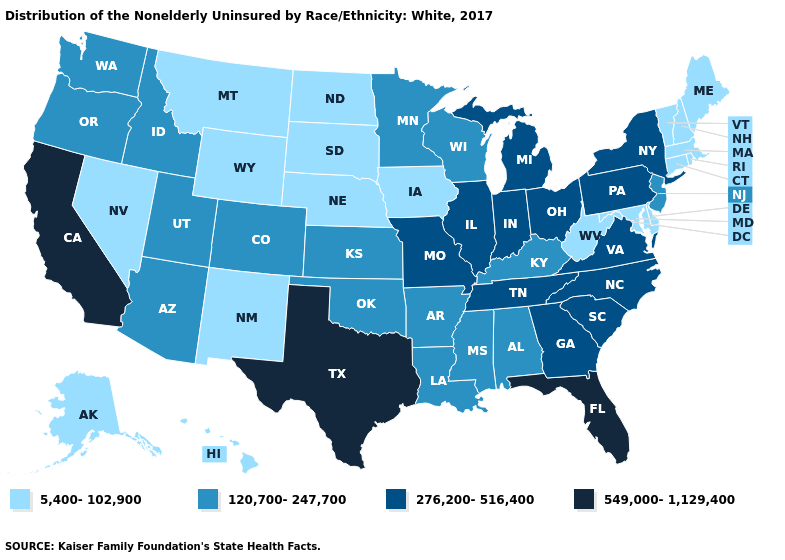Does Texas have the highest value in the USA?
Be succinct. Yes. Name the states that have a value in the range 5,400-102,900?
Give a very brief answer. Alaska, Connecticut, Delaware, Hawaii, Iowa, Maine, Maryland, Massachusetts, Montana, Nebraska, Nevada, New Hampshire, New Mexico, North Dakota, Rhode Island, South Dakota, Vermont, West Virginia, Wyoming. What is the value of Virginia?
Short answer required. 276,200-516,400. Does the map have missing data?
Give a very brief answer. No. Name the states that have a value in the range 276,200-516,400?
Concise answer only. Georgia, Illinois, Indiana, Michigan, Missouri, New York, North Carolina, Ohio, Pennsylvania, South Carolina, Tennessee, Virginia. Which states have the lowest value in the USA?
Short answer required. Alaska, Connecticut, Delaware, Hawaii, Iowa, Maine, Maryland, Massachusetts, Montana, Nebraska, Nevada, New Hampshire, New Mexico, North Dakota, Rhode Island, South Dakota, Vermont, West Virginia, Wyoming. What is the value of New Mexico?
Be succinct. 5,400-102,900. Name the states that have a value in the range 5,400-102,900?
Write a very short answer. Alaska, Connecticut, Delaware, Hawaii, Iowa, Maine, Maryland, Massachusetts, Montana, Nebraska, Nevada, New Hampshire, New Mexico, North Dakota, Rhode Island, South Dakota, Vermont, West Virginia, Wyoming. What is the value of Georgia?
Be succinct. 276,200-516,400. What is the value of Wisconsin?
Answer briefly. 120,700-247,700. What is the lowest value in states that border Wisconsin?
Short answer required. 5,400-102,900. What is the value of Hawaii?
Answer briefly. 5,400-102,900. Does Wyoming have a higher value than Nebraska?
Short answer required. No. Which states have the lowest value in the South?
Quick response, please. Delaware, Maryland, West Virginia. Name the states that have a value in the range 120,700-247,700?
Quick response, please. Alabama, Arizona, Arkansas, Colorado, Idaho, Kansas, Kentucky, Louisiana, Minnesota, Mississippi, New Jersey, Oklahoma, Oregon, Utah, Washington, Wisconsin. 